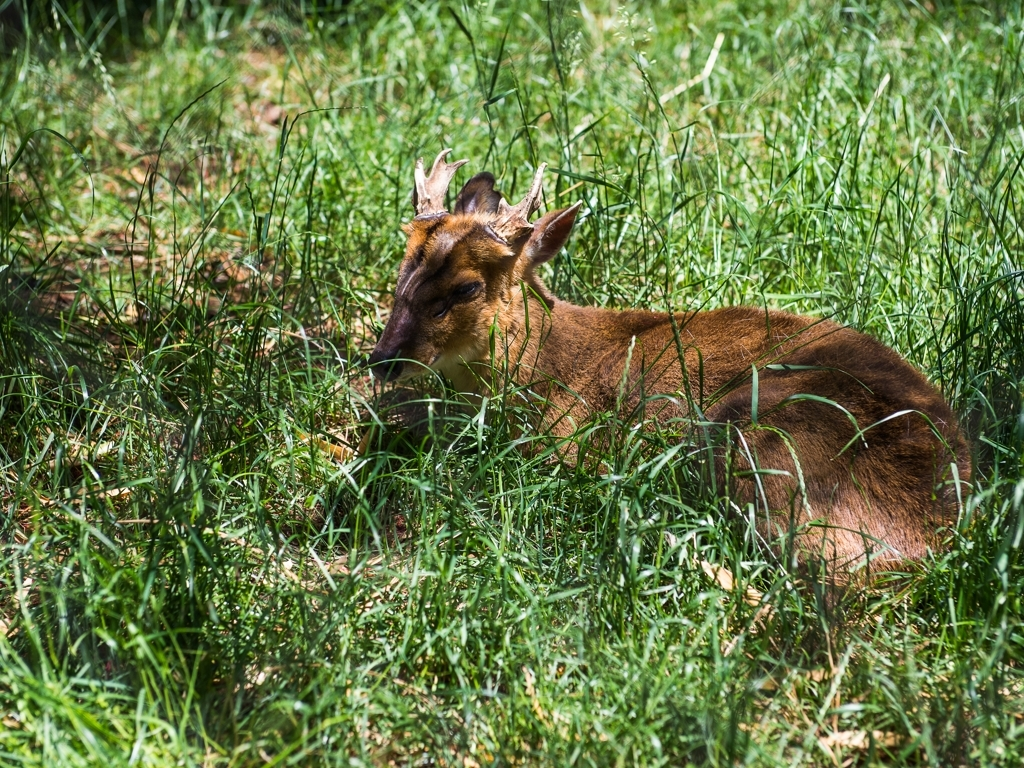Can you describe the environment in which the animal is found? The animal, which appears to be a deer, is resting in a natural setting with abundant grass around it. The grass is tall and green, suggesting that the environment is likely a meadow or open woodland during a season with ample rainfall. No human-made structures or objects are visible, which emphasizes the wildlife aspect of the shot. 